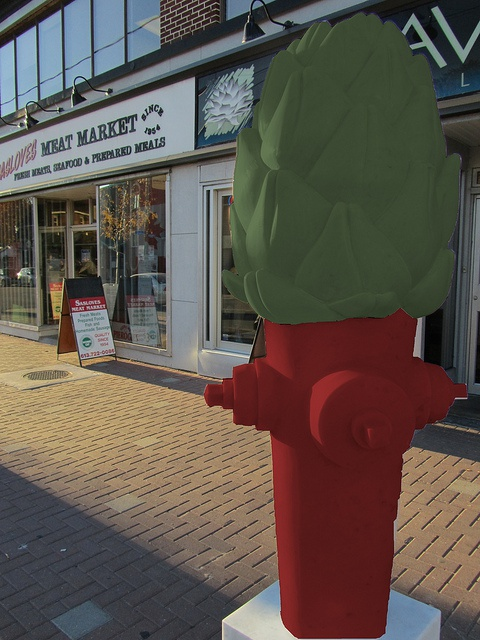Describe the objects in this image and their specific colors. I can see a fire hydrant in black, darkgreen, maroon, and brown tones in this image. 